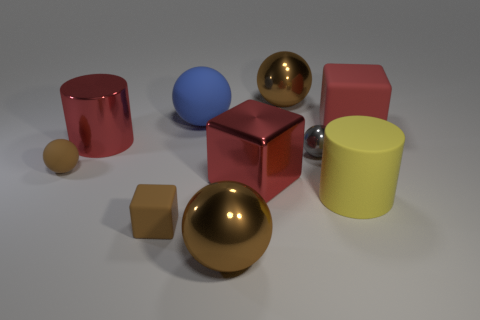There is a rubber thing that is the same color as the tiny matte sphere; what is its shape?
Your answer should be compact. Cube. There is a large ball that is in front of the matte thing in front of the yellow rubber cylinder; what is its color?
Provide a succinct answer. Brown. Are there more red objects in front of the tiny brown rubber cube than small spheres to the left of the big blue matte ball?
Make the answer very short. No. Do the large cylinder behind the yellow thing and the ball that is to the left of the small matte block have the same material?
Your answer should be compact. No. Are there any gray shiny objects in front of the yellow cylinder?
Give a very brief answer. No. How many brown things are rubber cubes or tiny metal things?
Provide a short and direct response. 1. Do the gray sphere and the red thing that is behind the red cylinder have the same material?
Provide a short and direct response. No. There is a metallic thing that is the same shape as the big yellow matte object; what size is it?
Offer a terse response. Large. What material is the tiny gray sphere?
Make the answer very short. Metal. What is the material of the large block behind the cylinder that is left of the large brown metallic ball that is in front of the blue sphere?
Your answer should be compact. Rubber. 